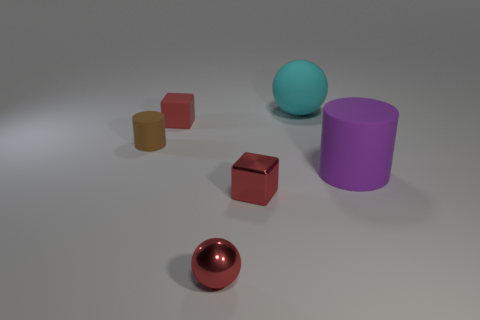What is the size of the other thing that is the same shape as the tiny red rubber object?
Offer a very short reply. Small. There is a brown rubber thing; what number of cyan matte objects are in front of it?
Provide a succinct answer. 0. There is a cylinder right of the rubber sphere; is its color the same as the metal ball?
Your answer should be compact. No. What number of red objects are tiny shiny cubes or matte objects?
Keep it short and to the point. 2. The tiny matte thing that is behind the rubber cylinder that is to the left of the big cyan matte thing is what color?
Provide a short and direct response. Red. What is the material of the tiny sphere that is the same color as the small rubber cube?
Your response must be concise. Metal. There is a cube that is right of the tiny metallic sphere; what is its color?
Your response must be concise. Red. Is the size of the purple matte thing that is in front of the brown matte thing the same as the big rubber sphere?
Your response must be concise. Yes. There is a shiny thing that is the same color as the metallic block; what size is it?
Your response must be concise. Small. Is there a blue cube that has the same size as the cyan ball?
Offer a terse response. No. 